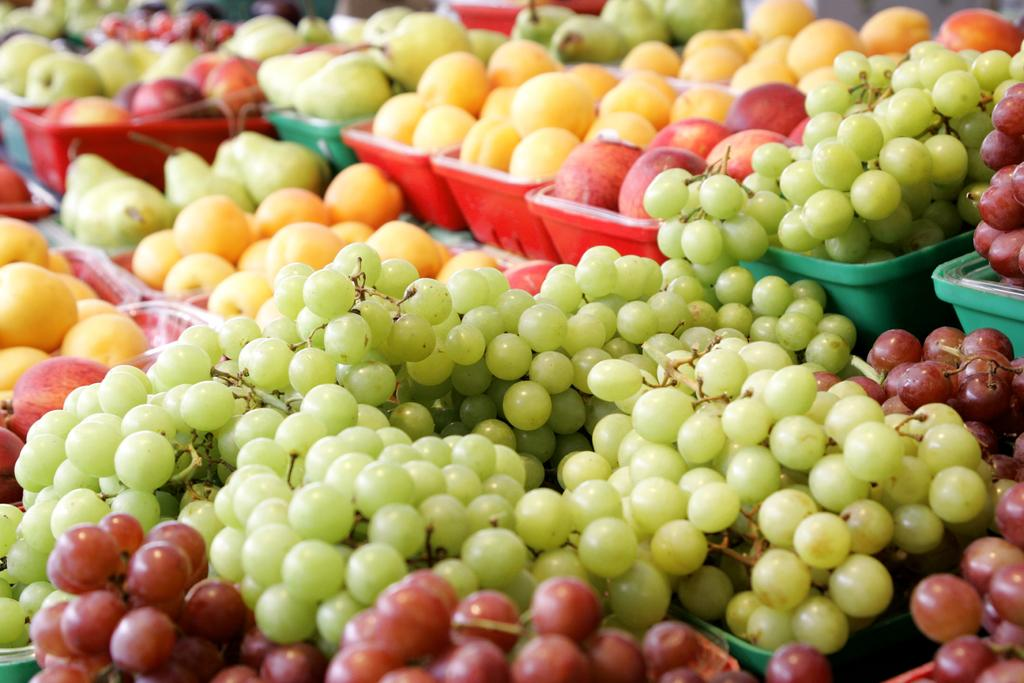What objects are present in the image that are used for holding items? There are trays in the image. What type of food can be seen in the trays? There are grapes, apples, and other fruits in the trays. What type of jelly can be seen in the image? There is no jelly present in the image; it features trays with fruits such as grapes, apples, and other fruits. 